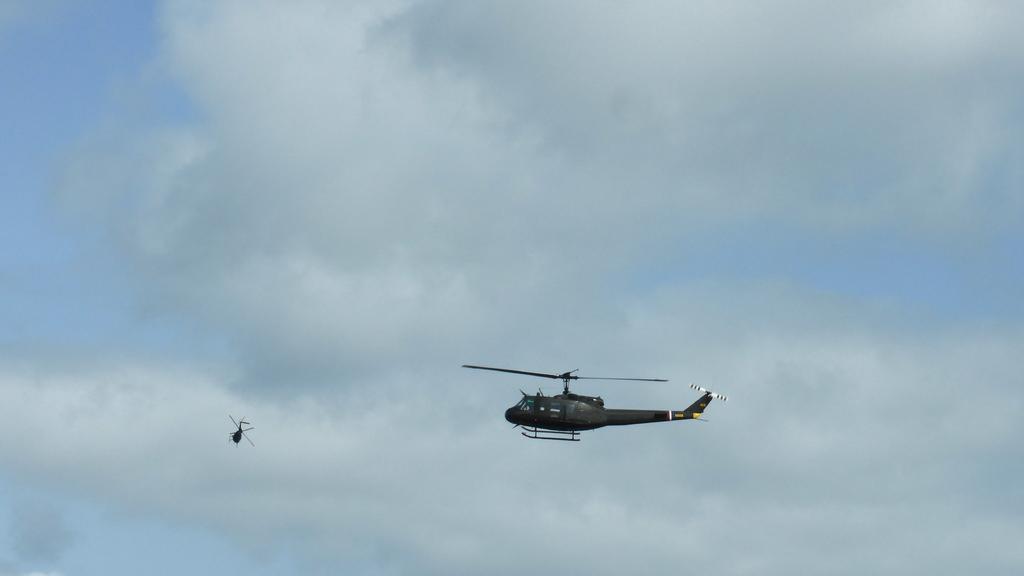How would you summarize this image in a sentence or two? In this image, we can see two helicopters are flying in the sky. Background there is a cloudy sky. 